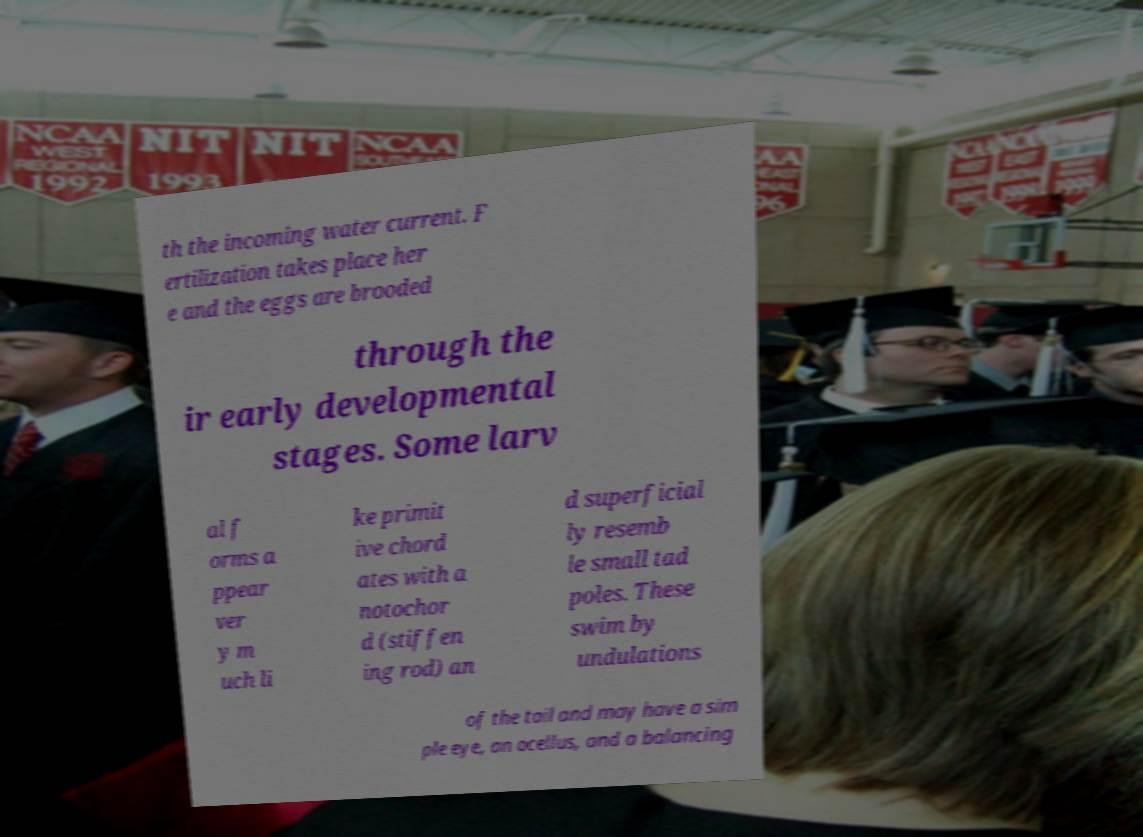Could you extract and type out the text from this image? th the incoming water current. F ertilization takes place her e and the eggs are brooded through the ir early developmental stages. Some larv al f orms a ppear ver y m uch li ke primit ive chord ates with a notochor d (stiffen ing rod) an d superficial ly resemb le small tad poles. These swim by undulations of the tail and may have a sim ple eye, an ocellus, and a balancing 